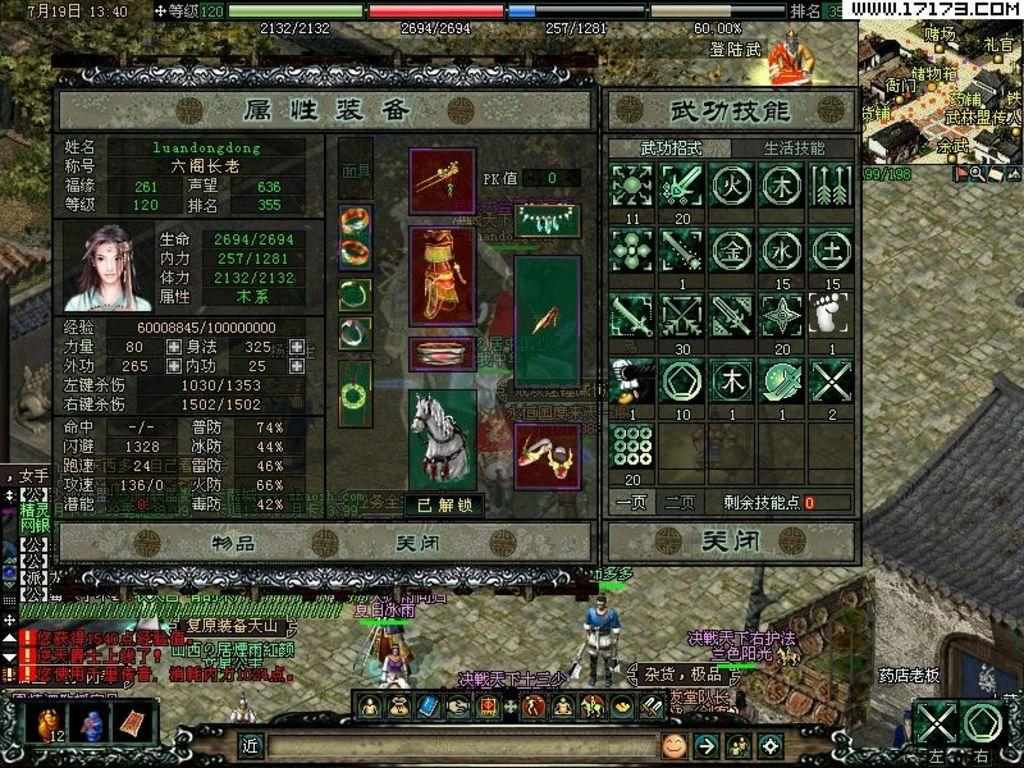What type of picture is in the image? The image contains an animated picture. What elements are present in the animation? There are figures, text, icons, a house, and people in the animation. Can you describe the figures in the animation? The figures in the animation are not specified, but they are part of the animated picture. What type of structure is present in the animation? There is a house in the animation. What type of linen is being used to cover the structure in the image? There is no linen present in the image, and the structure (house) is not being covered. What reward is being given to the people in the animation? There is no reward being given to the people in the animation; the image only shows the animated picture with various elements. 